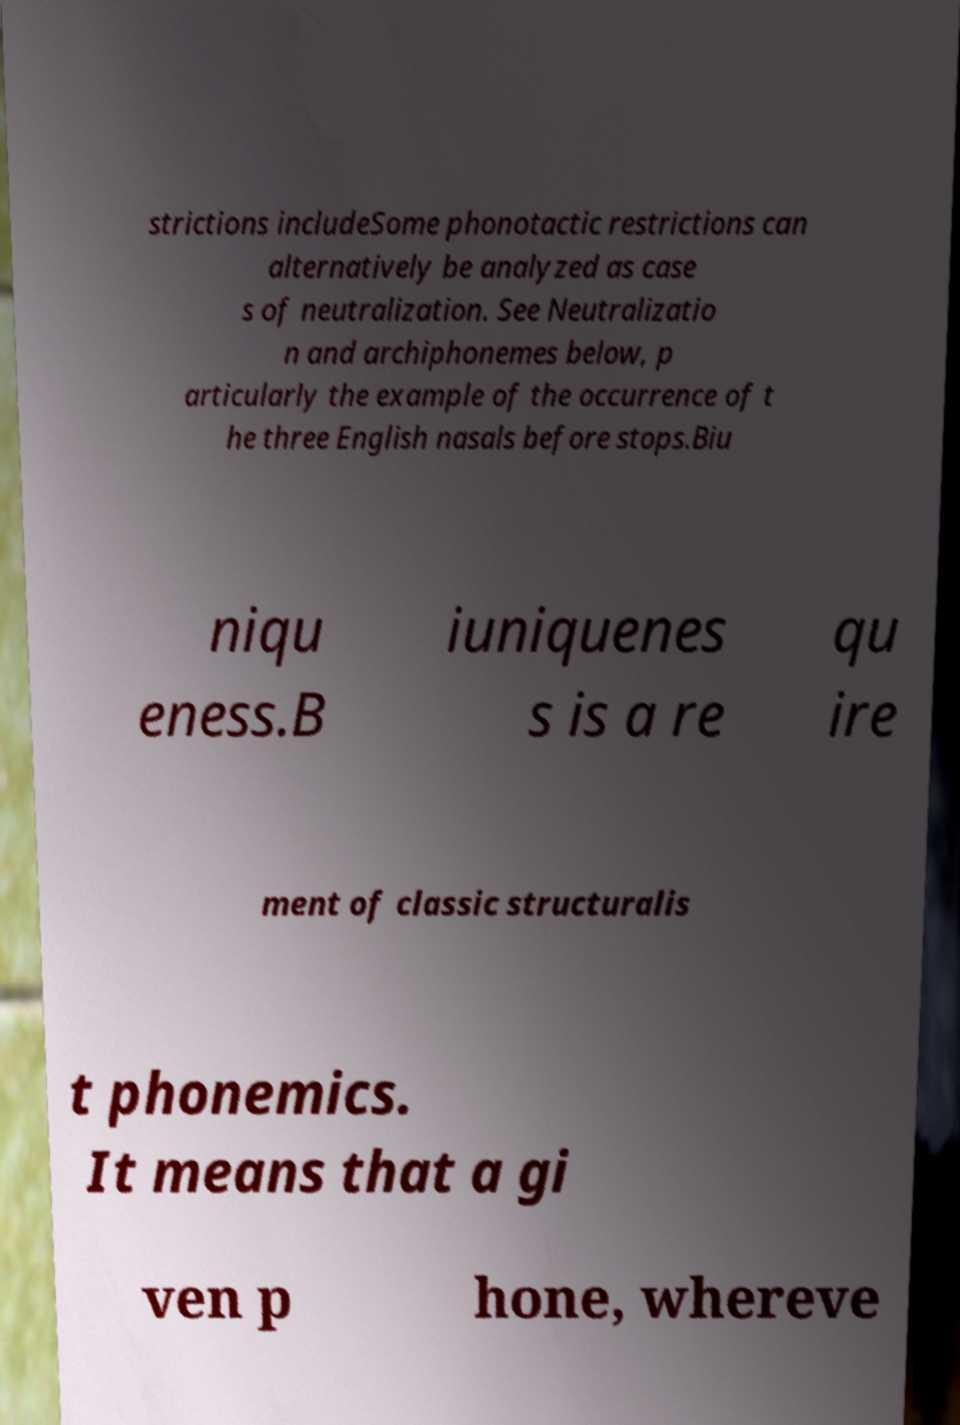Please identify and transcribe the text found in this image. strictions includeSome phonotactic restrictions can alternatively be analyzed as case s of neutralization. See Neutralizatio n and archiphonemes below, p articularly the example of the occurrence of t he three English nasals before stops.Biu niqu eness.B iuniquenes s is a re qu ire ment of classic structuralis t phonemics. It means that a gi ven p hone, whereve 